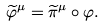<formula> <loc_0><loc_0><loc_500><loc_500>\widetilde { \varphi } ^ { \mu } = \widetilde { \pi } ^ { \mu } \circ \varphi .</formula> 